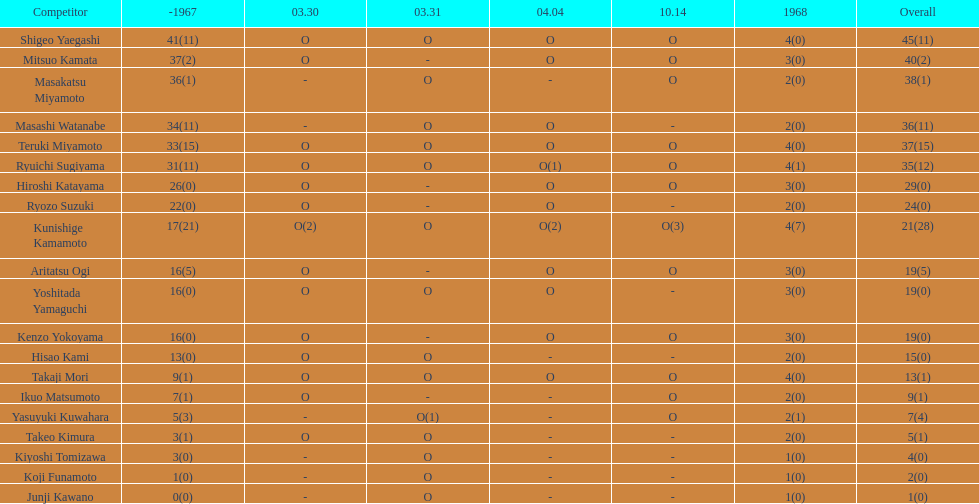How many total did mitsuo kamata have? 40(2). Give me the full table as a dictionary. {'header': ['Competitor', '-1967', '03.30', '03.31', '04.04', '10.14', '1968', 'Overall'], 'rows': [['Shigeo Yaegashi', '41(11)', 'O', 'O', 'O', 'O', '4(0)', '45(11)'], ['Mitsuo Kamata', '37(2)', 'O', '-', 'O', 'O', '3(0)', '40(2)'], ['Masakatsu Miyamoto', '36(1)', '-', 'O', '-', 'O', '2(0)', '38(1)'], ['Masashi Watanabe', '34(11)', '-', 'O', 'O', '-', '2(0)', '36(11)'], ['Teruki Miyamoto', '33(15)', 'O', 'O', 'O', 'O', '4(0)', '37(15)'], ['Ryuichi Sugiyama', '31(11)', 'O', 'O', 'O(1)', 'O', '4(1)', '35(12)'], ['Hiroshi Katayama', '26(0)', 'O', '-', 'O', 'O', '3(0)', '29(0)'], ['Ryozo Suzuki', '22(0)', 'O', '-', 'O', '-', '2(0)', '24(0)'], ['Kunishige Kamamoto', '17(21)', 'O(2)', 'O', 'O(2)', 'O(3)', '4(7)', '21(28)'], ['Aritatsu Ogi', '16(5)', 'O', '-', 'O', 'O', '3(0)', '19(5)'], ['Yoshitada Yamaguchi', '16(0)', 'O', 'O', 'O', '-', '3(0)', '19(0)'], ['Kenzo Yokoyama', '16(0)', 'O', '-', 'O', 'O', '3(0)', '19(0)'], ['Hisao Kami', '13(0)', 'O', 'O', '-', '-', '2(0)', '15(0)'], ['Takaji Mori', '9(1)', 'O', 'O', 'O', 'O', '4(0)', '13(1)'], ['Ikuo Matsumoto', '7(1)', 'O', '-', '-', 'O', '2(0)', '9(1)'], ['Yasuyuki Kuwahara', '5(3)', '-', 'O(1)', '-', 'O', '2(1)', '7(4)'], ['Takeo Kimura', '3(1)', 'O', 'O', '-', '-', '2(0)', '5(1)'], ['Kiyoshi Tomizawa', '3(0)', '-', 'O', '-', '-', '1(0)', '4(0)'], ['Koji Funamoto', '1(0)', '-', 'O', '-', '-', '1(0)', '2(0)'], ['Junji Kawano', '0(0)', '-', 'O', '-', '-', '1(0)', '1(0)']]} 